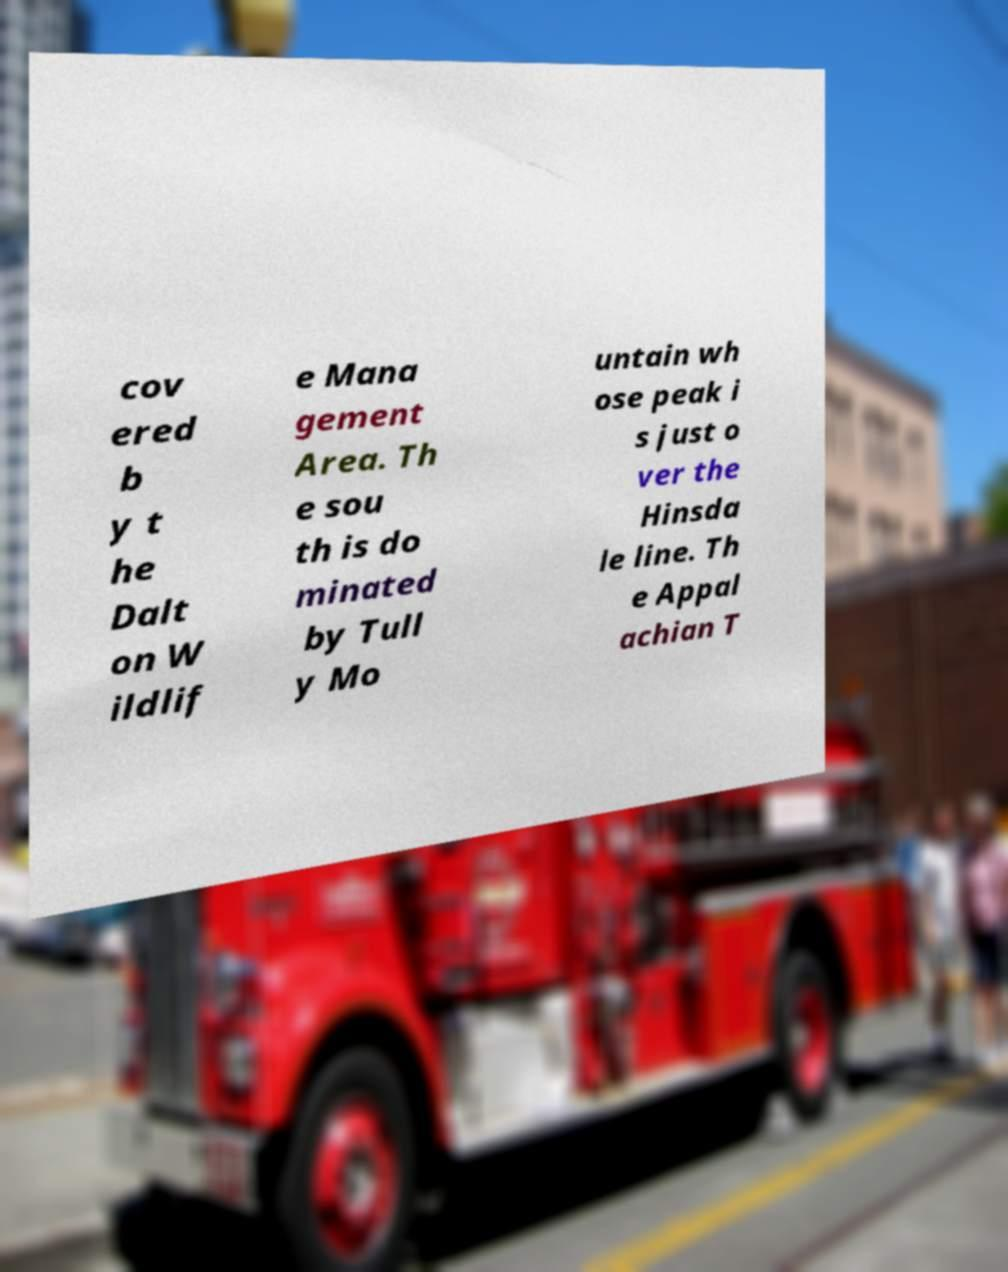What messages or text are displayed in this image? I need them in a readable, typed format. cov ered b y t he Dalt on W ildlif e Mana gement Area. Th e sou th is do minated by Tull y Mo untain wh ose peak i s just o ver the Hinsda le line. Th e Appal achian T 